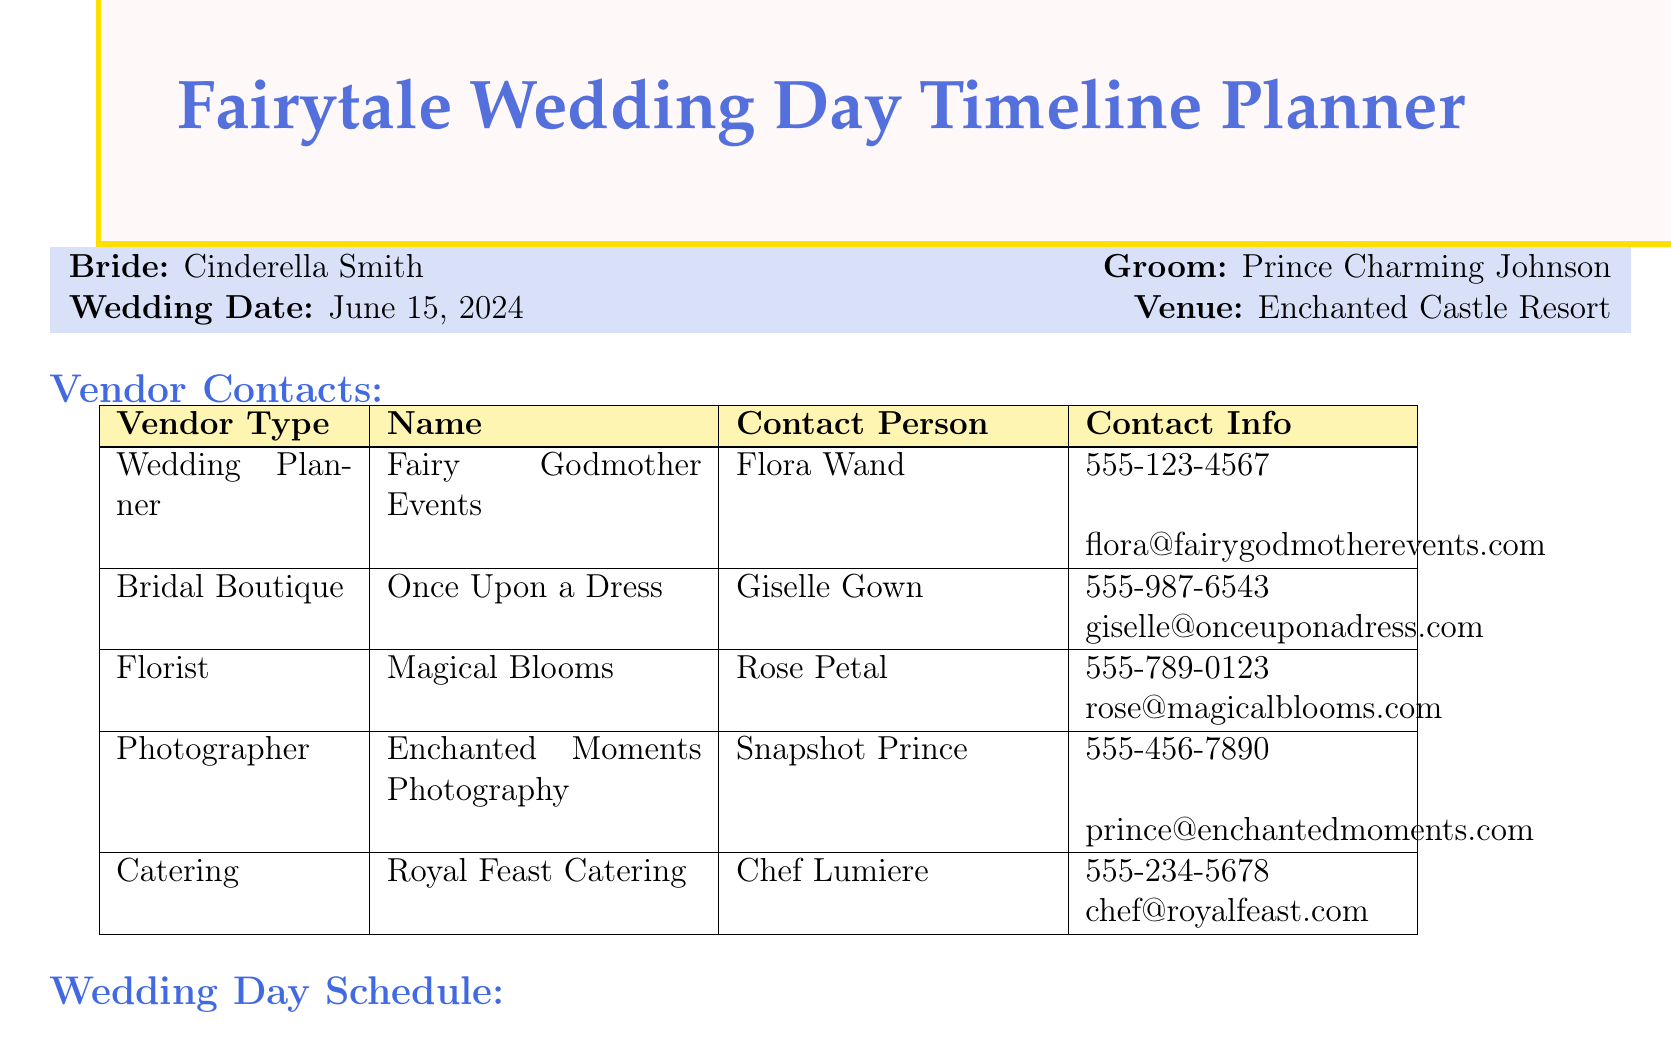What is the bride's name? The bride's name is listed as part of the brideInfo section of the document.
Answer: Cinderella Smith What is the wedding date? The wedding date is specified in the brideInfo section of the document.
Answer: June 15, 2024 Who is the contact person for the florist? The contact person for the florist is found in the vendorContacts section of the document.
Answer: Rose Petal What time does the ceremony begin? The ceremony start time is provided in the weddingDaySchedule section of the document.
Answer: 1:00 PM What is the activity planned at 4:15 PM? The activity scheduled for 4:15 PM can be located in the weddingDaySchedule section.
Answer: First dance What organization does the wedding planner represent? The vendor type of the wedding planner is detailed in the vendorContacts section.
Answer: Fairy Godmother Events How many emergency contacts are listed? The number of emergency contacts can be counted in the emergencyContacts section.
Answer: 3 What should the bride remember to bring at 8:00 AM? The notes for the activity at 8:00 AM mention specific items to bring.
Answer: Emergency dress repair kit and extra bobby pins What is the contact email for the catering vendor? The email address can be found under the vendorContacts section for the catering vendor.
Answer: chef@royalfeast.com 